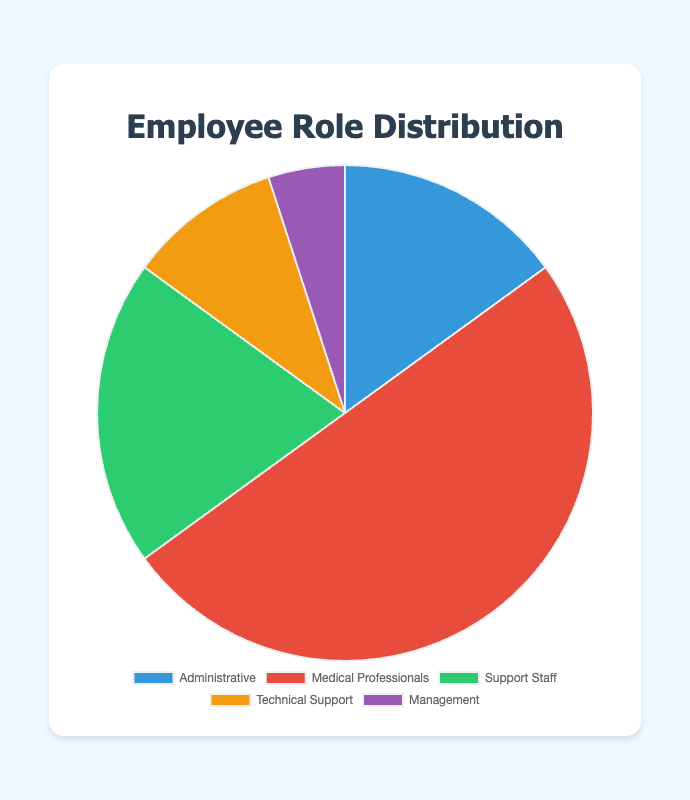Which role has the largest percentage of employees? The largest percentage of employees is represented by the role with the highest value in the pie chart. Medical Professionals represent 50%, which is the largest percentage.
Answer: Medical Professionals What is the combined percentage of Administrative and Support Staff roles? The percentages for Administrative and Support Staff roles are 15% and 20%, respectively. Adding these together: 15% + 20% = 35%.
Answer: 35% How many more employees are Medical Professionals compared to Management? Medical Professionals make up 50% and Management makes up 5%. The difference between these percentages is 50% - 5% = 45%.
Answer: 45% Which roles have a smaller percentage than Administrative? Administrative has 15%. Roles with smaller percentages are Technical Support (10%) and Management (5%).
Answer: Technical Support, Management What proportion of employees are not Medical Professionals? Medical Professionals make up 50%, so the proportion of employees who are not Medical Professionals is 100% - 50% = 50%.
Answer: 50% Which role is represented by the green color segment? The green color segment represents Support Staff, as indicated in the legend and the corresponding segment color.
Answer: Support Staff Compare the percentage of Technical Support and Management roles. Which is larger? Technical Support has 10% and Management has 5%. Since 10% is greater than 5%, Technical Support has a larger percentage.
Answer: Technical Support Infer the average percentage of the Administrative, Support Staff, Technical Support, and Management roles (excluding Medical Professionals). Sum the percentages: 15% (Administrative) + 20% (Support Staff) + 10% (Technical Support) + 5% (Management) = 50%. Average = 50% / 4 = 12.5%.
Answer: 12.5% If the company decides to increase Medical Professionals to 60%, what would be the new combined percentage of the remaining roles? If Medical Professionals increase from 50% to 60%, the remaining percentage would be 100% - 60% = 40%.
Answer: 40% Describe the color of the segment representing the smallest percentage of employees. The smallest percentage segment, representing Management with 5%, is purple.
Answer: Purple 